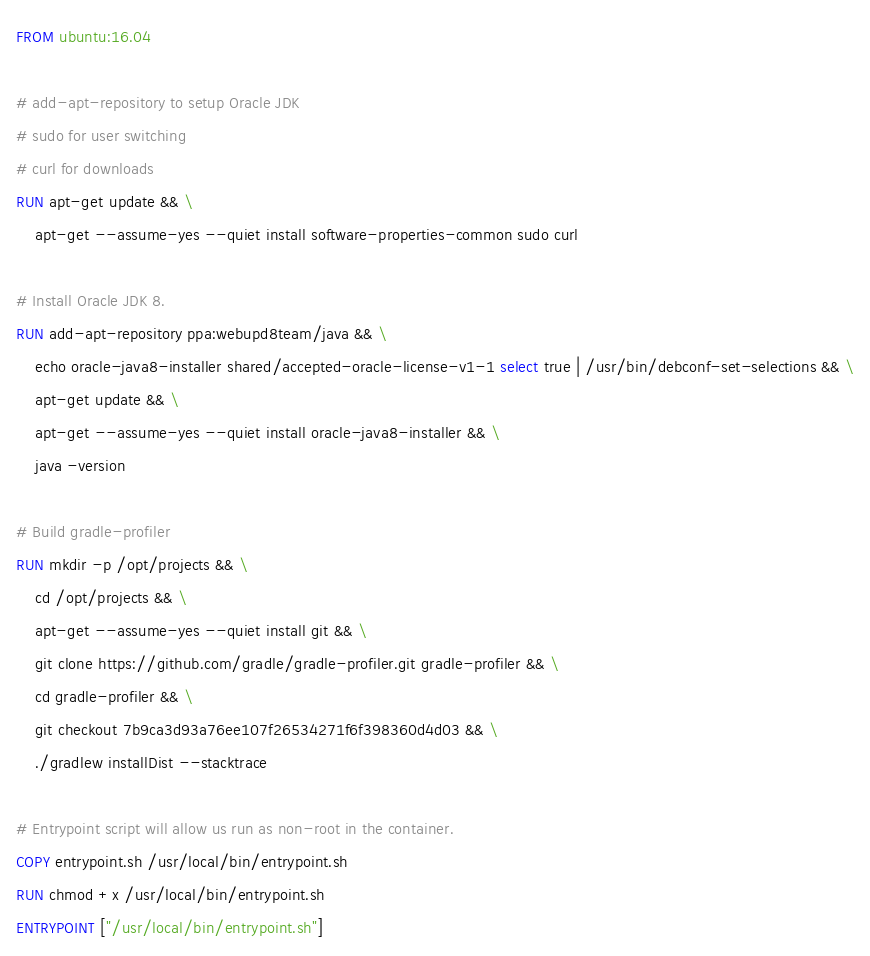Convert code to text. <code><loc_0><loc_0><loc_500><loc_500><_Dockerfile_>FROM ubuntu:16.04

# add-apt-repository to setup Oracle JDK
# sudo for user switching
# curl for downloads
RUN apt-get update && \
    apt-get --assume-yes --quiet install software-properties-common sudo curl

# Install Oracle JDK 8.
RUN add-apt-repository ppa:webupd8team/java && \
    echo oracle-java8-installer shared/accepted-oracle-license-v1-1 select true | /usr/bin/debconf-set-selections && \
    apt-get update && \
    apt-get --assume-yes --quiet install oracle-java8-installer && \
    java -version

# Build gradle-profiler
RUN mkdir -p /opt/projects && \
    cd /opt/projects && \
    apt-get --assume-yes --quiet install git && \
    git clone https://github.com/gradle/gradle-profiler.git gradle-profiler && \
    cd gradle-profiler && \
    git checkout 7b9ca3d93a76ee107f26534271f6f398360d4d03 && \
    ./gradlew installDist --stacktrace

# Entrypoint script will allow us run as non-root in the container.
COPY entrypoint.sh /usr/local/bin/entrypoint.sh
RUN chmod +x /usr/local/bin/entrypoint.sh
ENTRYPOINT ["/usr/local/bin/entrypoint.sh"]
</code> 